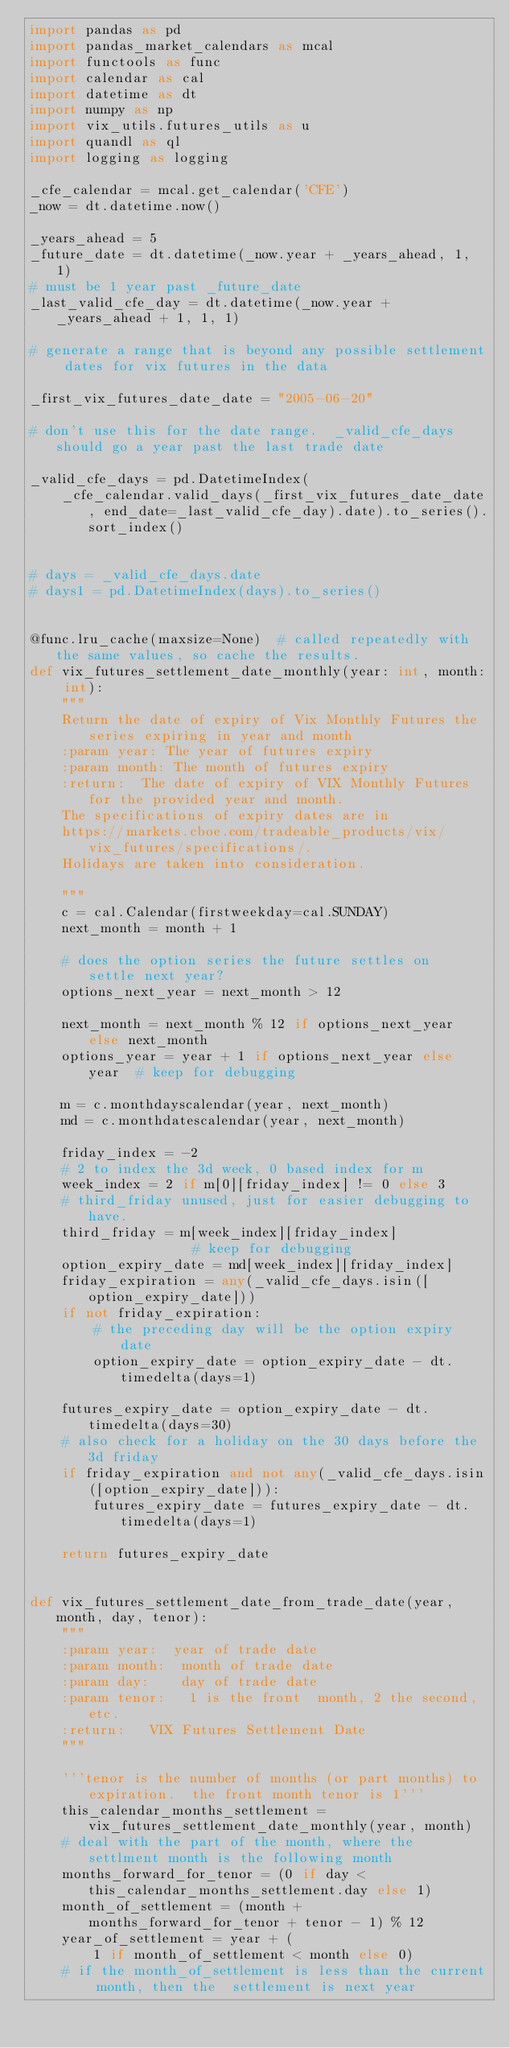<code> <loc_0><loc_0><loc_500><loc_500><_Python_>import pandas as pd
import pandas_market_calendars as mcal
import functools as func
import calendar as cal
import datetime as dt
import numpy as np
import vix_utils.futures_utils as u
import quandl as ql
import logging as logging

_cfe_calendar = mcal.get_calendar('CFE')
_now = dt.datetime.now()

_years_ahead = 5
_future_date = dt.datetime(_now.year + _years_ahead, 1, 1)
# must be 1 year past _future_date
_last_valid_cfe_day = dt.datetime(_now.year + _years_ahead + 1, 1, 1)

# generate a range that is beyond any possible settlement dates for vix futures in the data

_first_vix_futures_date_date = "2005-06-20"

# don't use this for the date range.  _valid_cfe_days should go a year past the last trade date

_valid_cfe_days = pd.DatetimeIndex(
    _cfe_calendar.valid_days(_first_vix_futures_date_date, end_date=_last_valid_cfe_day).date).to_series().sort_index()


# days = _valid_cfe_days.date
# days1 = pd.DatetimeIndex(days).to_series()


@func.lru_cache(maxsize=None)  # called repeatedly with the same values, so cache the results.
def vix_futures_settlement_date_monthly(year: int, month: int):
    """
    Return the date of expiry of Vix Monthly Futures the series expiring in year and month
    :param year: The year of futures expiry
    :param month: The month of futures expiry
    :return:  The date of expiry of VIX Monthly Futures for the provided year and month.
    The specifications of expiry dates are in
    https://markets.cboe.com/tradeable_products/vix/vix_futures/specifications/.
    Holidays are taken into consideration.

    """
    c = cal.Calendar(firstweekday=cal.SUNDAY)
    next_month = month + 1

    # does the option series the future settles on  settle next year?
    options_next_year = next_month > 12

    next_month = next_month % 12 if options_next_year else next_month
    options_year = year + 1 if options_next_year else year  # keep for debugging

    m = c.monthdayscalendar(year, next_month)
    md = c.monthdatescalendar(year, next_month)

    friday_index = -2
    # 2 to index the 3d week, 0 based index for m
    week_index = 2 if m[0][friday_index] != 0 else 3
    # third_friday unused, just for easier debugging to have.
    third_friday = m[week_index][friday_index]              # keep for debugging
    option_expiry_date = md[week_index][friday_index]
    friday_expiration = any(_valid_cfe_days.isin([option_expiry_date]))
    if not friday_expiration:
        # the preceding day will be the option expiry date
        option_expiry_date = option_expiry_date - dt.timedelta(days=1)

    futures_expiry_date = option_expiry_date - dt.timedelta(days=30)
    # also check for a holiday on the 30 days before the 3d friday
    if friday_expiration and not any(_valid_cfe_days.isin([option_expiry_date])):
        futures_expiry_date = futures_expiry_date - dt.timedelta(days=1)

    return futures_expiry_date


def vix_futures_settlement_date_from_trade_date(year, month, day, tenor):
    """
    :param year:  year of trade date
    :param month:  month of trade date
    :param day:    day of trade date
    :param tenor:   1 is the front  month, 2 the second, etc.
    :return:   VIX Futures Settlement Date
    """

    '''tenor is the number of months (or part months) to expiration.  the front month tenor is 1'''
    this_calendar_months_settlement = vix_futures_settlement_date_monthly(year, month)
    # deal with the part of the month, where the settlment month is the following month
    months_forward_for_tenor = (0 if day < this_calendar_months_settlement.day else 1)
    month_of_settlement = (month + months_forward_for_tenor + tenor - 1) % 12
    year_of_settlement = year + (
        1 if month_of_settlement < month else 0)
    # if the month_of_settlement is less than the current month, then the  settlement is next year</code> 